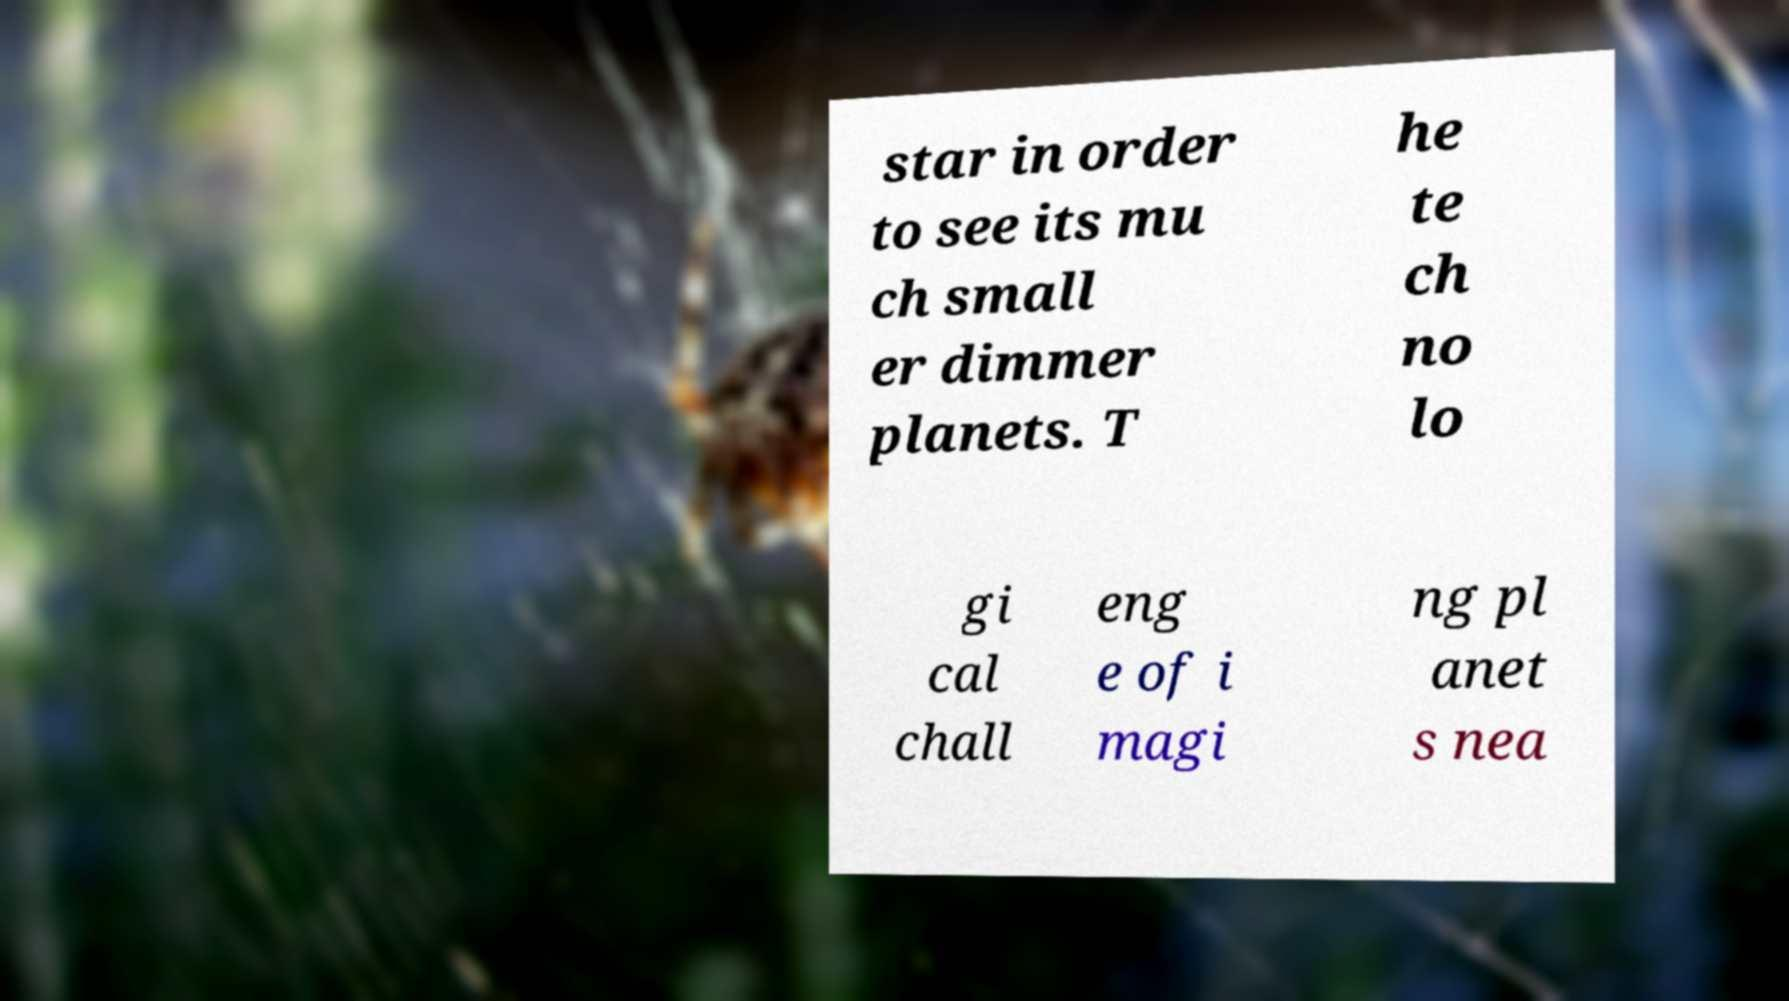Could you extract and type out the text from this image? star in order to see its mu ch small er dimmer planets. T he te ch no lo gi cal chall eng e of i magi ng pl anet s nea 